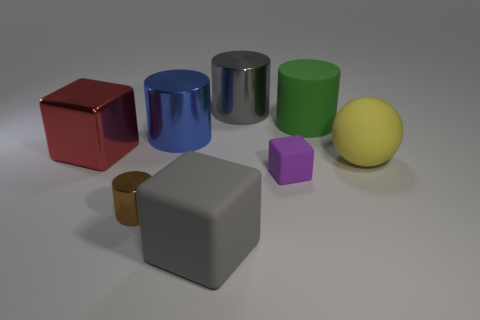What is the shape of the big object that is the same color as the big matte cube?
Provide a succinct answer. Cylinder. Is the number of blocks to the left of the brown metallic cylinder greater than the number of big metal cubes in front of the tiny cube?
Your answer should be very brief. Yes. Do the large blue cylinder and the small thing that is to the right of the small brown object have the same material?
Your answer should be very brief. No. There is a small object that is left of the matte cube behind the brown metallic cylinder; what number of small purple rubber cubes are to the left of it?
Provide a succinct answer. 0. Is the shape of the blue thing the same as the big gray object that is in front of the small purple thing?
Keep it short and to the point. No. There is a large matte thing that is in front of the big green cylinder and to the left of the big yellow matte ball; what is its color?
Offer a very short reply. Gray. What is the block to the right of the big shiny cylinder on the right side of the big matte object in front of the tiny purple matte object made of?
Offer a very short reply. Rubber. What material is the large yellow sphere?
Provide a short and direct response. Rubber. What is the size of the brown metallic object that is the same shape as the large green object?
Offer a very short reply. Small. Is the tiny rubber object the same color as the big metal cube?
Provide a succinct answer. No. 